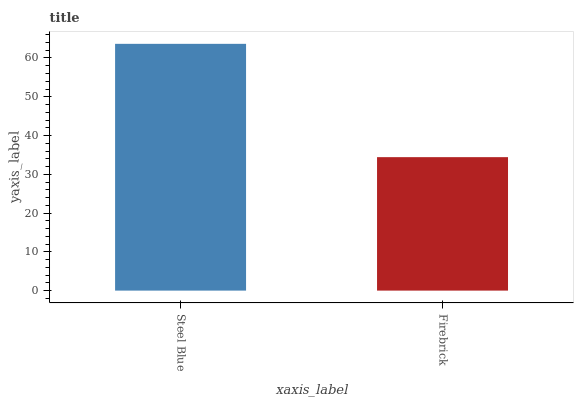Is Firebrick the maximum?
Answer yes or no. No. Is Steel Blue greater than Firebrick?
Answer yes or no. Yes. Is Firebrick less than Steel Blue?
Answer yes or no. Yes. Is Firebrick greater than Steel Blue?
Answer yes or no. No. Is Steel Blue less than Firebrick?
Answer yes or no. No. Is Steel Blue the high median?
Answer yes or no. Yes. Is Firebrick the low median?
Answer yes or no. Yes. Is Firebrick the high median?
Answer yes or no. No. Is Steel Blue the low median?
Answer yes or no. No. 